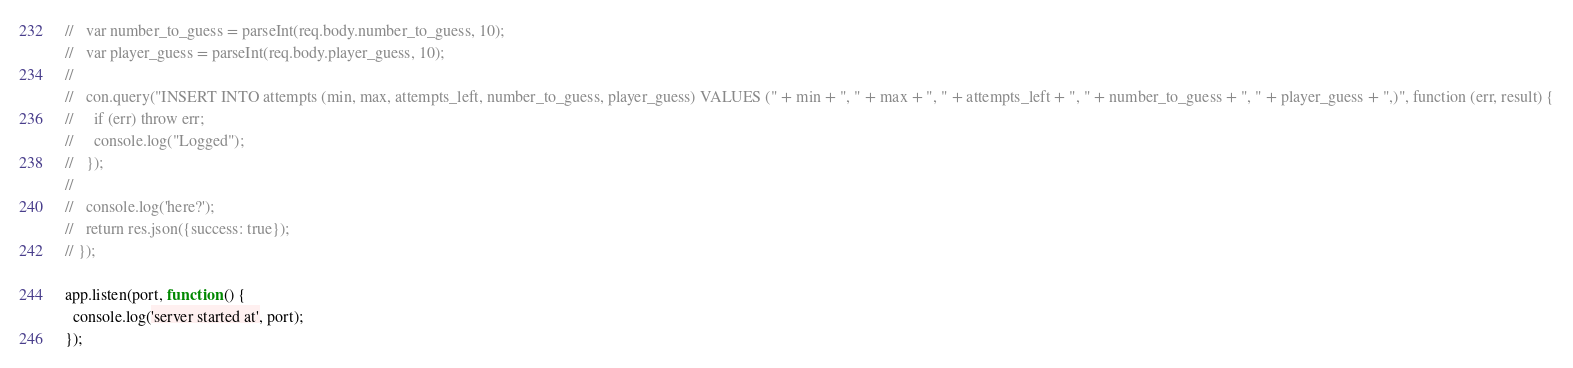Convert code to text. <code><loc_0><loc_0><loc_500><loc_500><_JavaScript_>//   var number_to_guess = parseInt(req.body.number_to_guess, 10);
//   var player_guess = parseInt(req.body.player_guess, 10);
//
//   con.query("INSERT INTO attempts (min, max, attempts_left, number_to_guess, player_guess) VALUES (" + min + ", " + max + ", " + attempts_left + ", " + number_to_guess + ", " + player_guess + ",)", function (err, result) {
//     if (err) throw err;
//     console.log("Logged");
//   });
//
//   console.log('here?');
//   return res.json({success: true});
// });

app.listen(port, function () {
  console.log('server started at', port);
});
</code> 